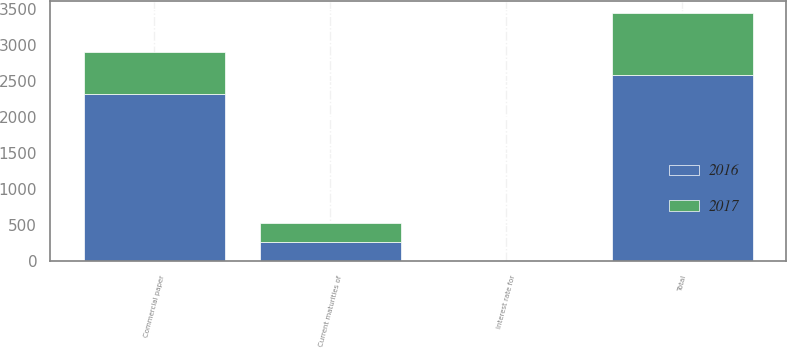<chart> <loc_0><loc_0><loc_500><loc_500><stacked_bar_chart><ecel><fcel>Current maturities of<fcel>Commercial paper<fcel>Total<fcel>Interest rate for<nl><fcel>2016<fcel>267<fcel>2317<fcel>2584<fcel>0.5<nl><fcel>2017<fcel>270<fcel>592<fcel>862<fcel>1.1<nl></chart> 